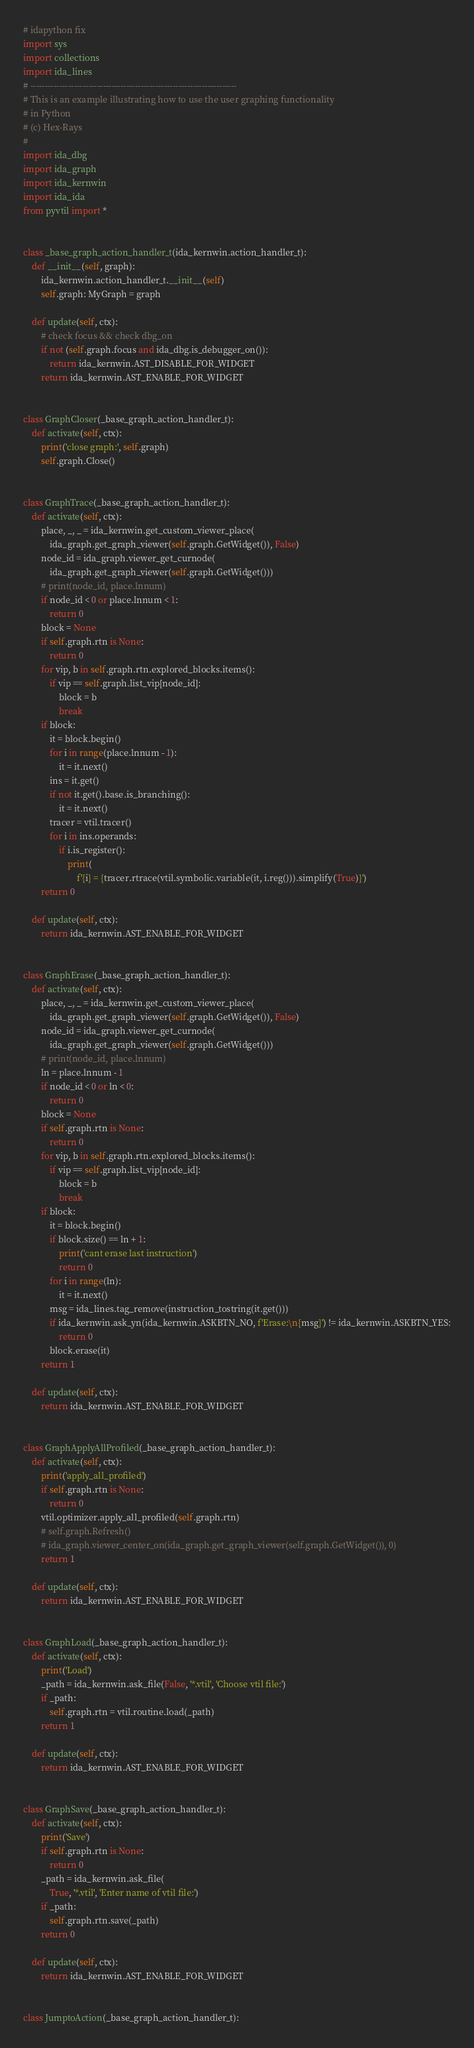<code> <loc_0><loc_0><loc_500><loc_500><_Python_># idapython fix
import sys
import collections
import ida_lines
# -----------------------------------------------------------------------
# This is an example illustrating how to use the user graphing functionality
# in Python
# (c) Hex-Rays
#
import ida_dbg
import ida_graph
import ida_kernwin
import ida_ida
from pyvtil import *


class _base_graph_action_handler_t(ida_kernwin.action_handler_t):
    def __init__(self, graph):
        ida_kernwin.action_handler_t.__init__(self)
        self.graph: MyGraph = graph

    def update(self, ctx):
        # check focus && check dbg_on
        if not (self.graph.focus and ida_dbg.is_debugger_on()):
            return ida_kernwin.AST_DISABLE_FOR_WIDGET
        return ida_kernwin.AST_ENABLE_FOR_WIDGET


class GraphCloser(_base_graph_action_handler_t):
    def activate(self, ctx):
        print('close graph:', self.graph)
        self.graph.Close()


class GraphTrace(_base_graph_action_handler_t):
    def activate(self, ctx):
        place, _, _ = ida_kernwin.get_custom_viewer_place(
            ida_graph.get_graph_viewer(self.graph.GetWidget()), False)
        node_id = ida_graph.viewer_get_curnode(
            ida_graph.get_graph_viewer(self.graph.GetWidget()))
        # print(node_id, place.lnnum)
        if node_id < 0 or place.lnnum < 1:
            return 0
        block = None
        if self.graph.rtn is None:
            return 0
        for vip, b in self.graph.rtn.explored_blocks.items():
            if vip == self.graph.list_vip[node_id]:
                block = b
                break
        if block:
            it = block.begin()
            for i in range(place.lnnum - 1):
                it = it.next()
            ins = it.get()
            if not it.get().base.is_branching():
                it = it.next()
            tracer = vtil.tracer()
            for i in ins.operands:
                if i.is_register():
                    print(
                        f'{i} = {tracer.rtrace(vtil.symbolic.variable(it, i.reg())).simplify(True)}')
        return 0

    def update(self, ctx):
        return ida_kernwin.AST_ENABLE_FOR_WIDGET


class GraphErase(_base_graph_action_handler_t):
    def activate(self, ctx):
        place, _, _ = ida_kernwin.get_custom_viewer_place(
            ida_graph.get_graph_viewer(self.graph.GetWidget()), False)
        node_id = ida_graph.viewer_get_curnode(
            ida_graph.get_graph_viewer(self.graph.GetWidget()))
        # print(node_id, place.lnnum)
        ln = place.lnnum - 1
        if node_id < 0 or ln < 0:
            return 0
        block = None
        if self.graph.rtn is None:
            return 0
        for vip, b in self.graph.rtn.explored_blocks.items():
            if vip == self.graph.list_vip[node_id]:
                block = b
                break
        if block:
            it = block.begin()
            if block.size() == ln + 1:
                print('cant erase last instruction')
                return 0
            for i in range(ln):
                it = it.next()
            msg = ida_lines.tag_remove(instruction_tostring(it.get()))
            if ida_kernwin.ask_yn(ida_kernwin.ASKBTN_NO, f'Erase:\n{msg}') != ida_kernwin.ASKBTN_YES:
                return 0
            block.erase(it)
        return 1

    def update(self, ctx):
        return ida_kernwin.AST_ENABLE_FOR_WIDGET


class GraphApplyAllProfiled(_base_graph_action_handler_t):
    def activate(self, ctx):
        print('apply_all_profiled')
        if self.graph.rtn is None:
            return 0
        vtil.optimizer.apply_all_profiled(self.graph.rtn)
        # self.graph.Refresh()
        # ida_graph.viewer_center_on(ida_graph.get_graph_viewer(self.graph.GetWidget()), 0)
        return 1

    def update(self, ctx):
        return ida_kernwin.AST_ENABLE_FOR_WIDGET


class GraphLoad(_base_graph_action_handler_t):
    def activate(self, ctx):
        print('Load')
        _path = ida_kernwin.ask_file(False, '*.vtil', 'Choose vtil file:')
        if _path:
            self.graph.rtn = vtil.routine.load(_path)
        return 1

    def update(self, ctx):
        return ida_kernwin.AST_ENABLE_FOR_WIDGET


class GraphSave(_base_graph_action_handler_t):
    def activate(self, ctx):
        print('Save')
        if self.graph.rtn is None:
            return 0
        _path = ida_kernwin.ask_file(
            True, '*.vtil', 'Enter name of vtil file:')
        if _path:
            self.graph.rtn.save(_path)
        return 0

    def update(self, ctx):
        return ida_kernwin.AST_ENABLE_FOR_WIDGET


class JumptoAction(_base_graph_action_handler_t):</code> 